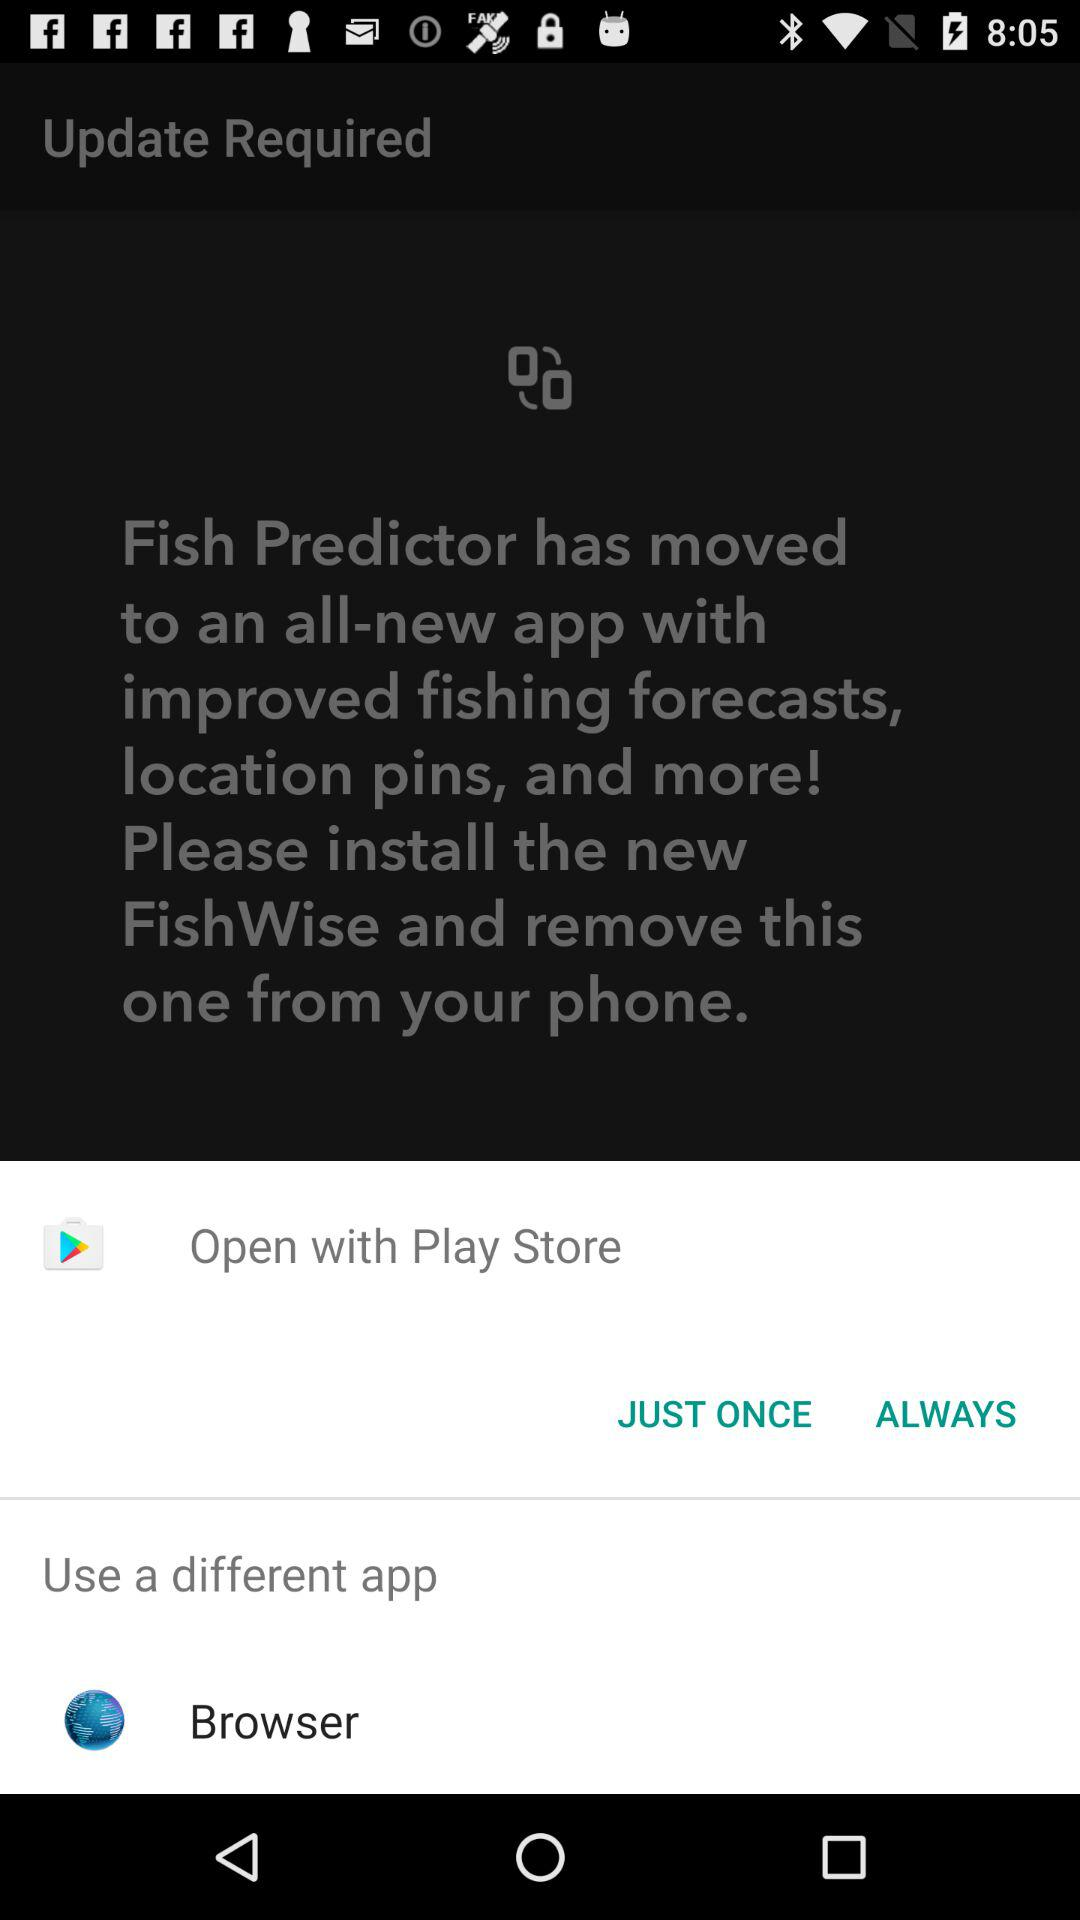What is the name of the new application? The name of the new application is "FishWise". 